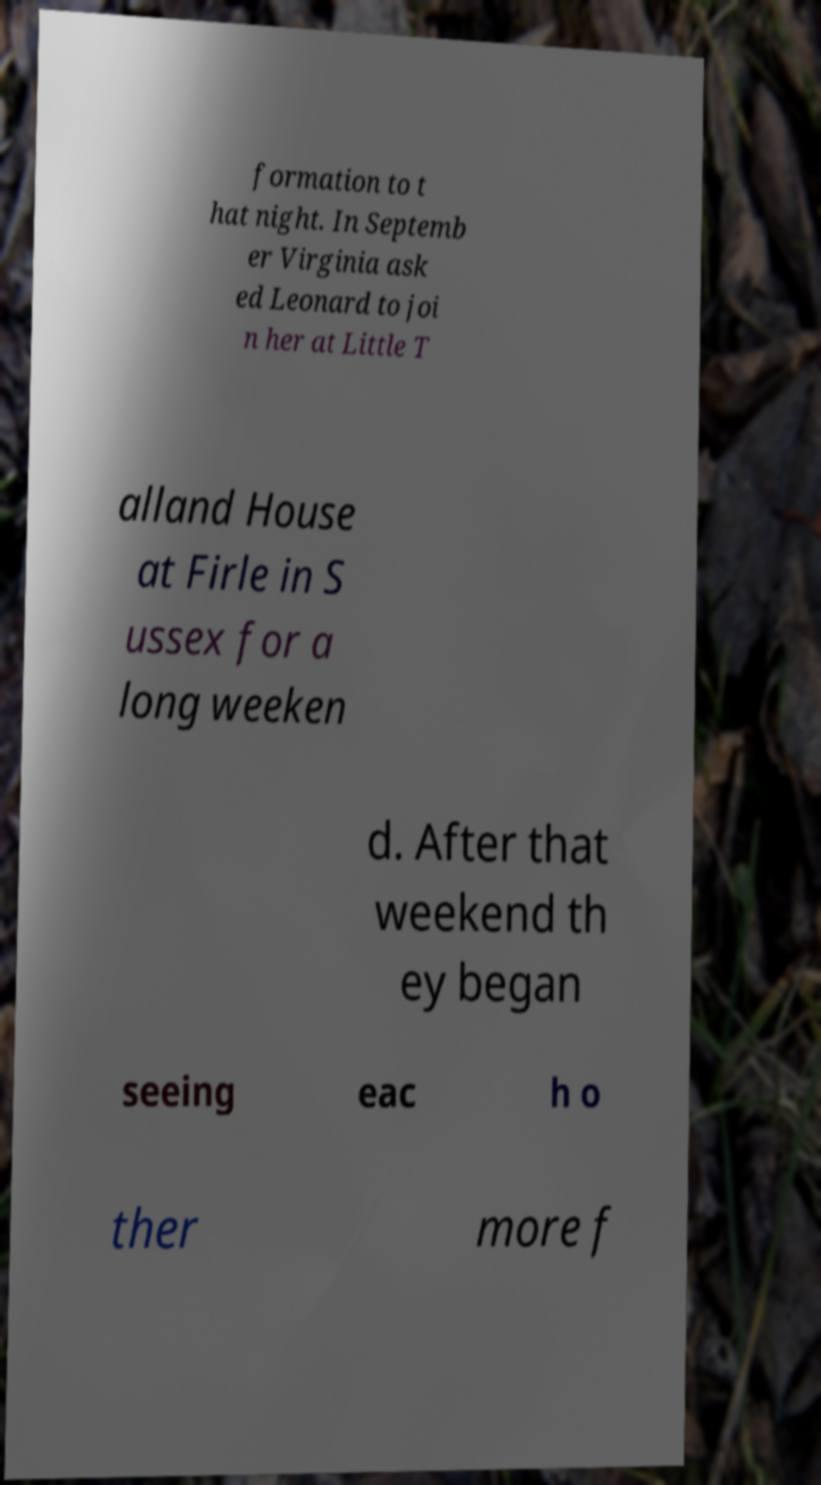Could you assist in decoding the text presented in this image and type it out clearly? formation to t hat night. In Septemb er Virginia ask ed Leonard to joi n her at Little T alland House at Firle in S ussex for a long weeken d. After that weekend th ey began seeing eac h o ther more f 